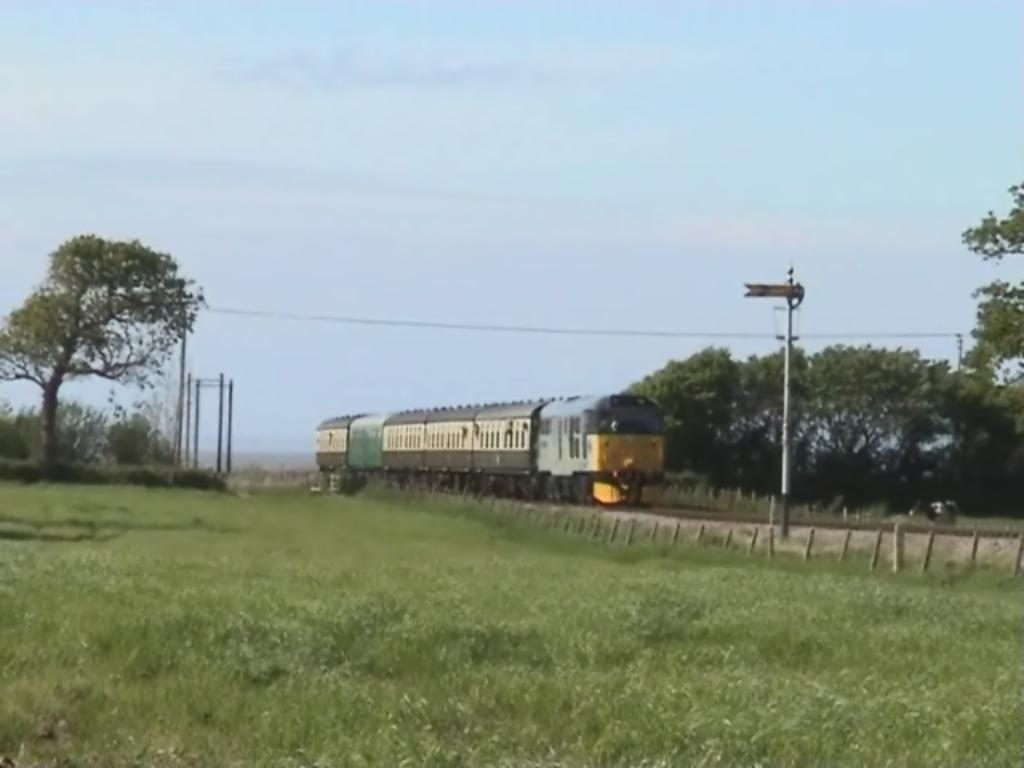What is the main subject of the image? The main subject of the image is a train. Where is the train located in the image? The train is on a railway track in the image. What type of vegetation can be seen in the image? There are trees and grass visible in the image. What else can be seen in the image besides the train and vegetation? There are poles and the sky visible in the image. What is the weight of the crook in the image? There is no crook present in the image, so it is not possible to determine its weight. 